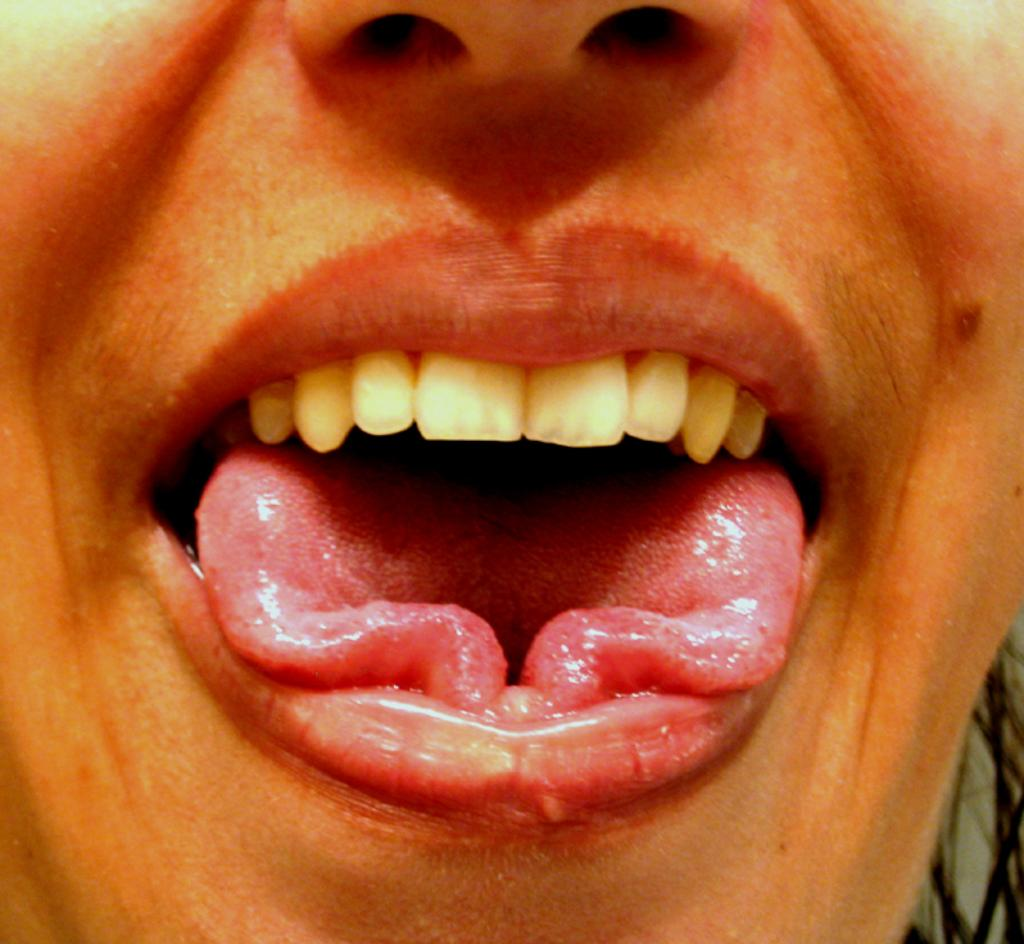What is the main feature in the image? The main feature in the image is a mouth. What can be found inside the mouth? The mouth contains a tongue and upper teeth. What other facial feature is present in the image? There is a nose in the image. How many trucks can be seen driving through the mouth in the image? There are no trucks present in the image; it features a mouth with a tongue and upper teeth. Can you describe the twist of the tongue in the image? The image does not show any twisting of the tongue; it simply depicts a tongue inside the mouth. 